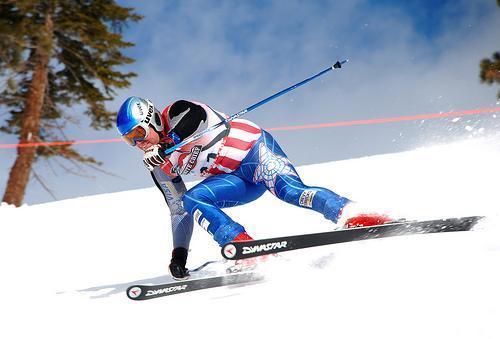How many people are shown?
Give a very brief answer. 1. How many skis are shown?
Give a very brief answer. 2. 